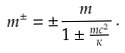Convert formula to latex. <formula><loc_0><loc_0><loc_500><loc_500>m ^ { \pm } = \pm \frac { m } { 1 \pm \frac { m c ^ { 2 } } { \kappa } } \, .</formula> 